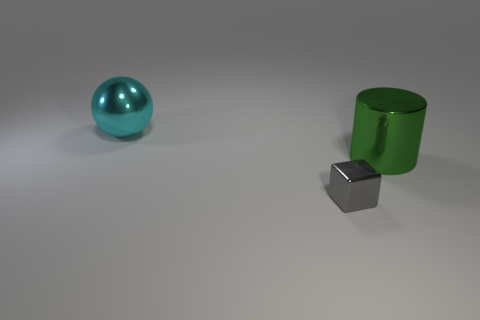What might be the purpose of this arrangement? The arrangement seems to be deliberately spaced, perhaps for a visualization of geometric shapes or a study in perspective. It's a simplistic setup that could serve educational purposes or be part of a 3D modeling and rendering exercise to practice object creation and lighting effects. 